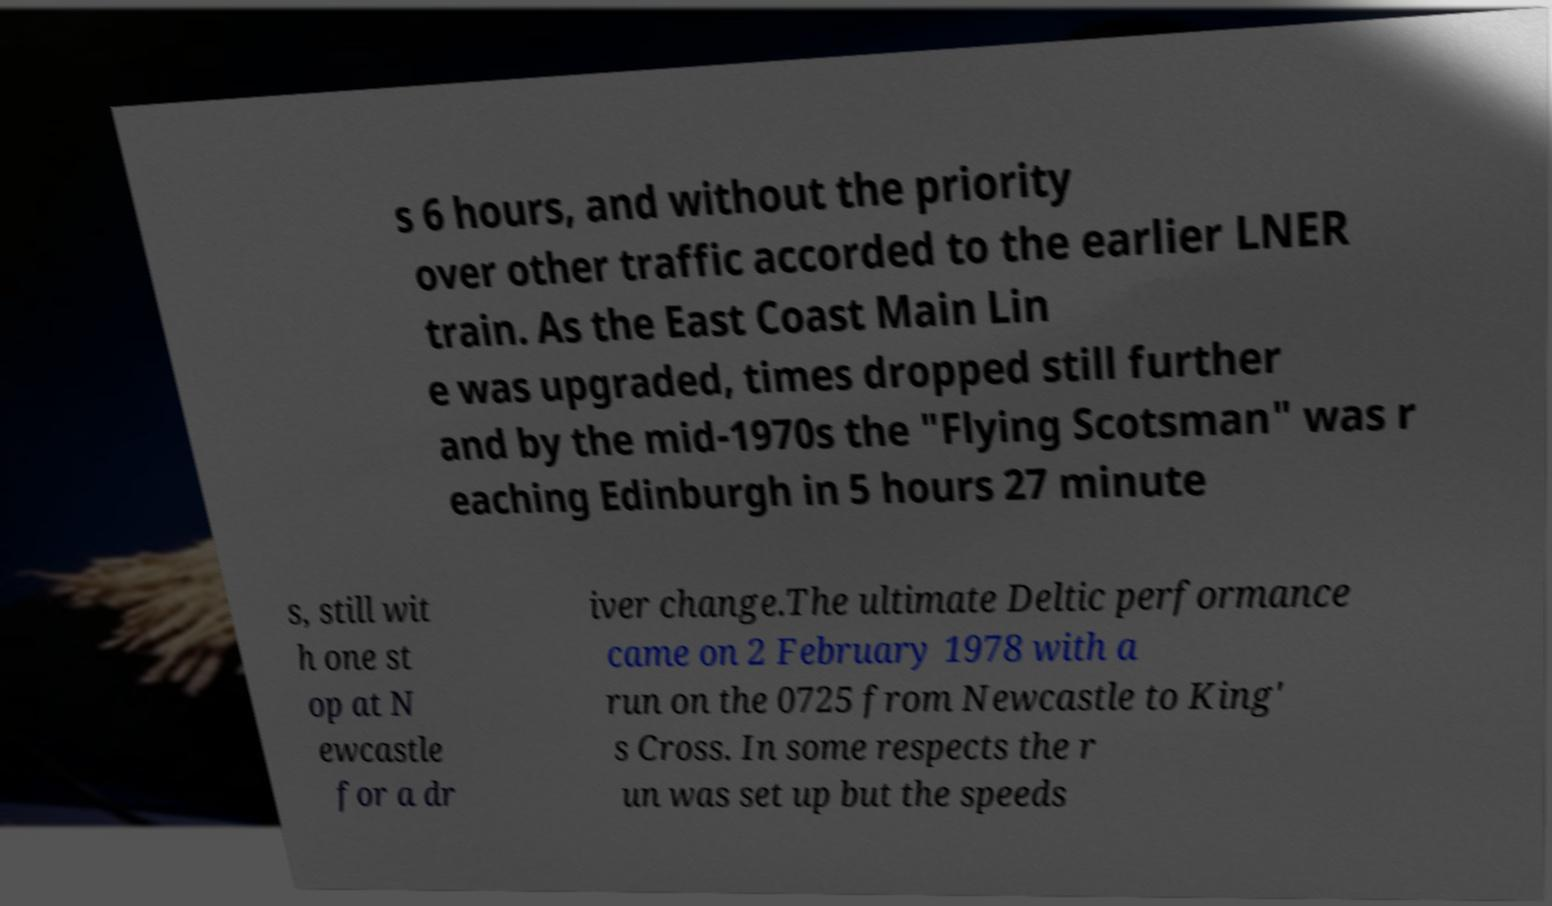Please read and relay the text visible in this image. What does it say? s 6 hours, and without the priority over other traffic accorded to the earlier LNER train. As the East Coast Main Lin e was upgraded, times dropped still further and by the mid-1970s the "Flying Scotsman" was r eaching Edinburgh in 5 hours 27 minute s, still wit h one st op at N ewcastle for a dr iver change.The ultimate Deltic performance came on 2 February 1978 with a run on the 0725 from Newcastle to King' s Cross. In some respects the r un was set up but the speeds 